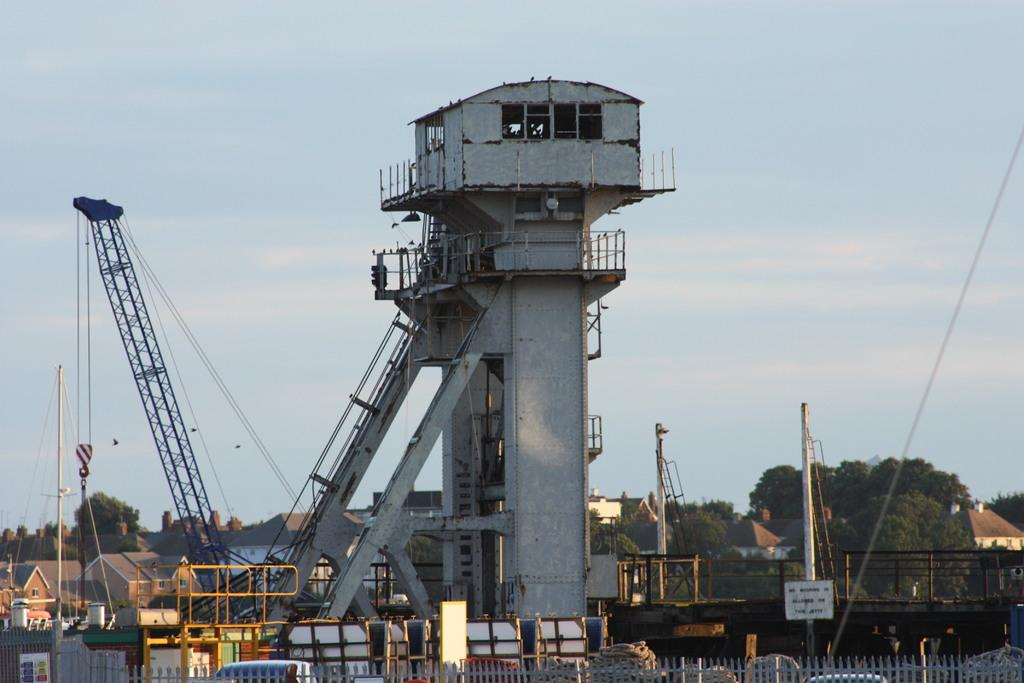What is the main structure in the center of the image? There is a tower in the center of the image. What type of machinery can be seen in the image? There is a crane in the image. What is located at the bottom of the image? There is a fence at the bottom of the image. What types of vehicles are visible in the image? Vehicles are visible in the image. What can be seen in the background of the image? There are buildings, trees, and the sky visible in the background of the image. What type of sugar is being used to sweeten the title of the image? There is no sugar or title present in the image; it is a photograph of a tower, crane, fence, vehicles, and the background. Can you see a frog hopping around in the image? There is no frog present in the image. 